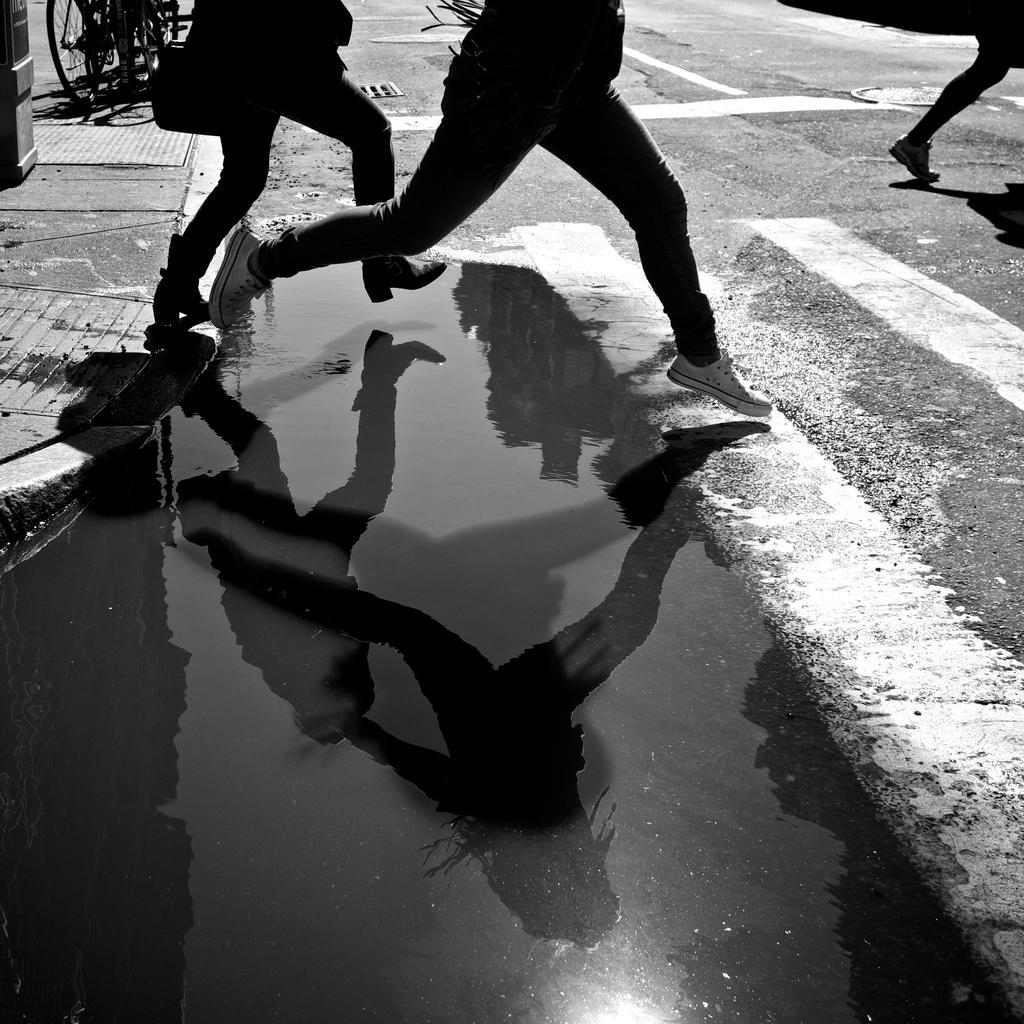Could you give a brief overview of what you see in this image? In this picture I can see the water in the foreground. I can see people. I can see bicycles on the walkway. I can see the road. 